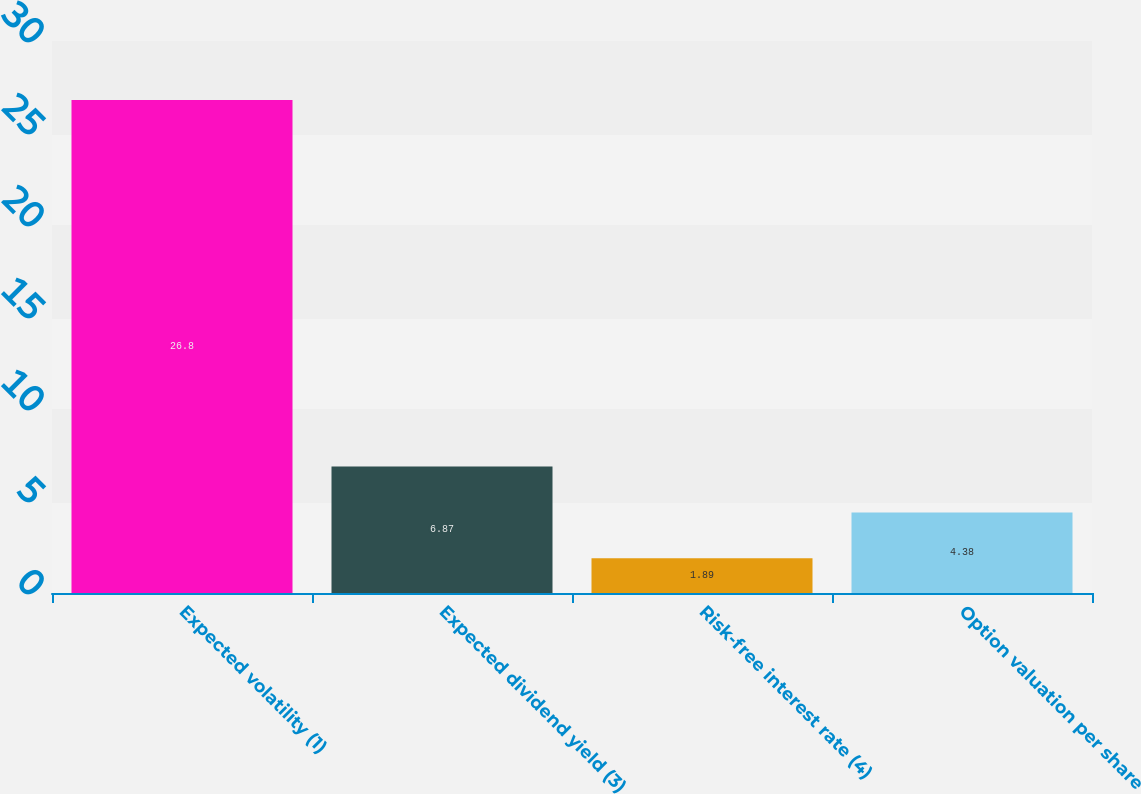Convert chart to OTSL. <chart><loc_0><loc_0><loc_500><loc_500><bar_chart><fcel>Expected volatility (1)<fcel>Expected dividend yield (3)<fcel>Risk-free interest rate (4)<fcel>Option valuation per share<nl><fcel>26.8<fcel>6.87<fcel>1.89<fcel>4.38<nl></chart> 